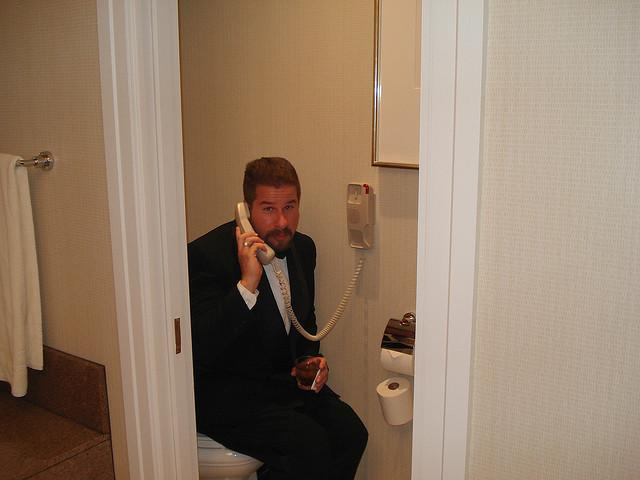What is he doing?

Choices:
A) cleaning up
B) speaking phone
C) hiding himself
D) hiding drink speaking phone 